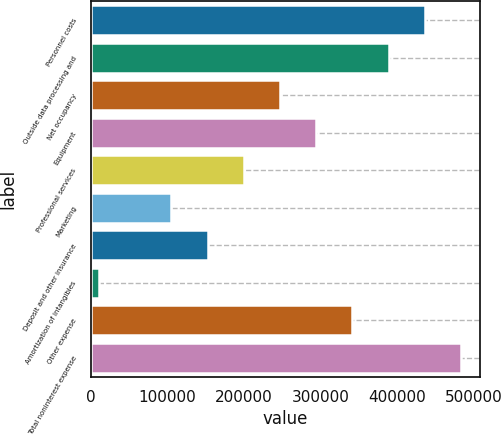Convert chart to OTSL. <chart><loc_0><loc_0><loc_500><loc_500><bar_chart><fcel>Personnel costs<fcel>Outside data processing and<fcel>Net occupancy<fcel>Equipment<fcel>Professional services<fcel>Marketing<fcel>Deposit and other insurance<fcel>Amortization of intangibles<fcel>Other expense<fcel>Total noninterest expense<nl><fcel>436009<fcel>388747<fcel>246962<fcel>294224<fcel>199700<fcel>105177<fcel>152438<fcel>10653<fcel>341486<fcel>483271<nl></chart> 